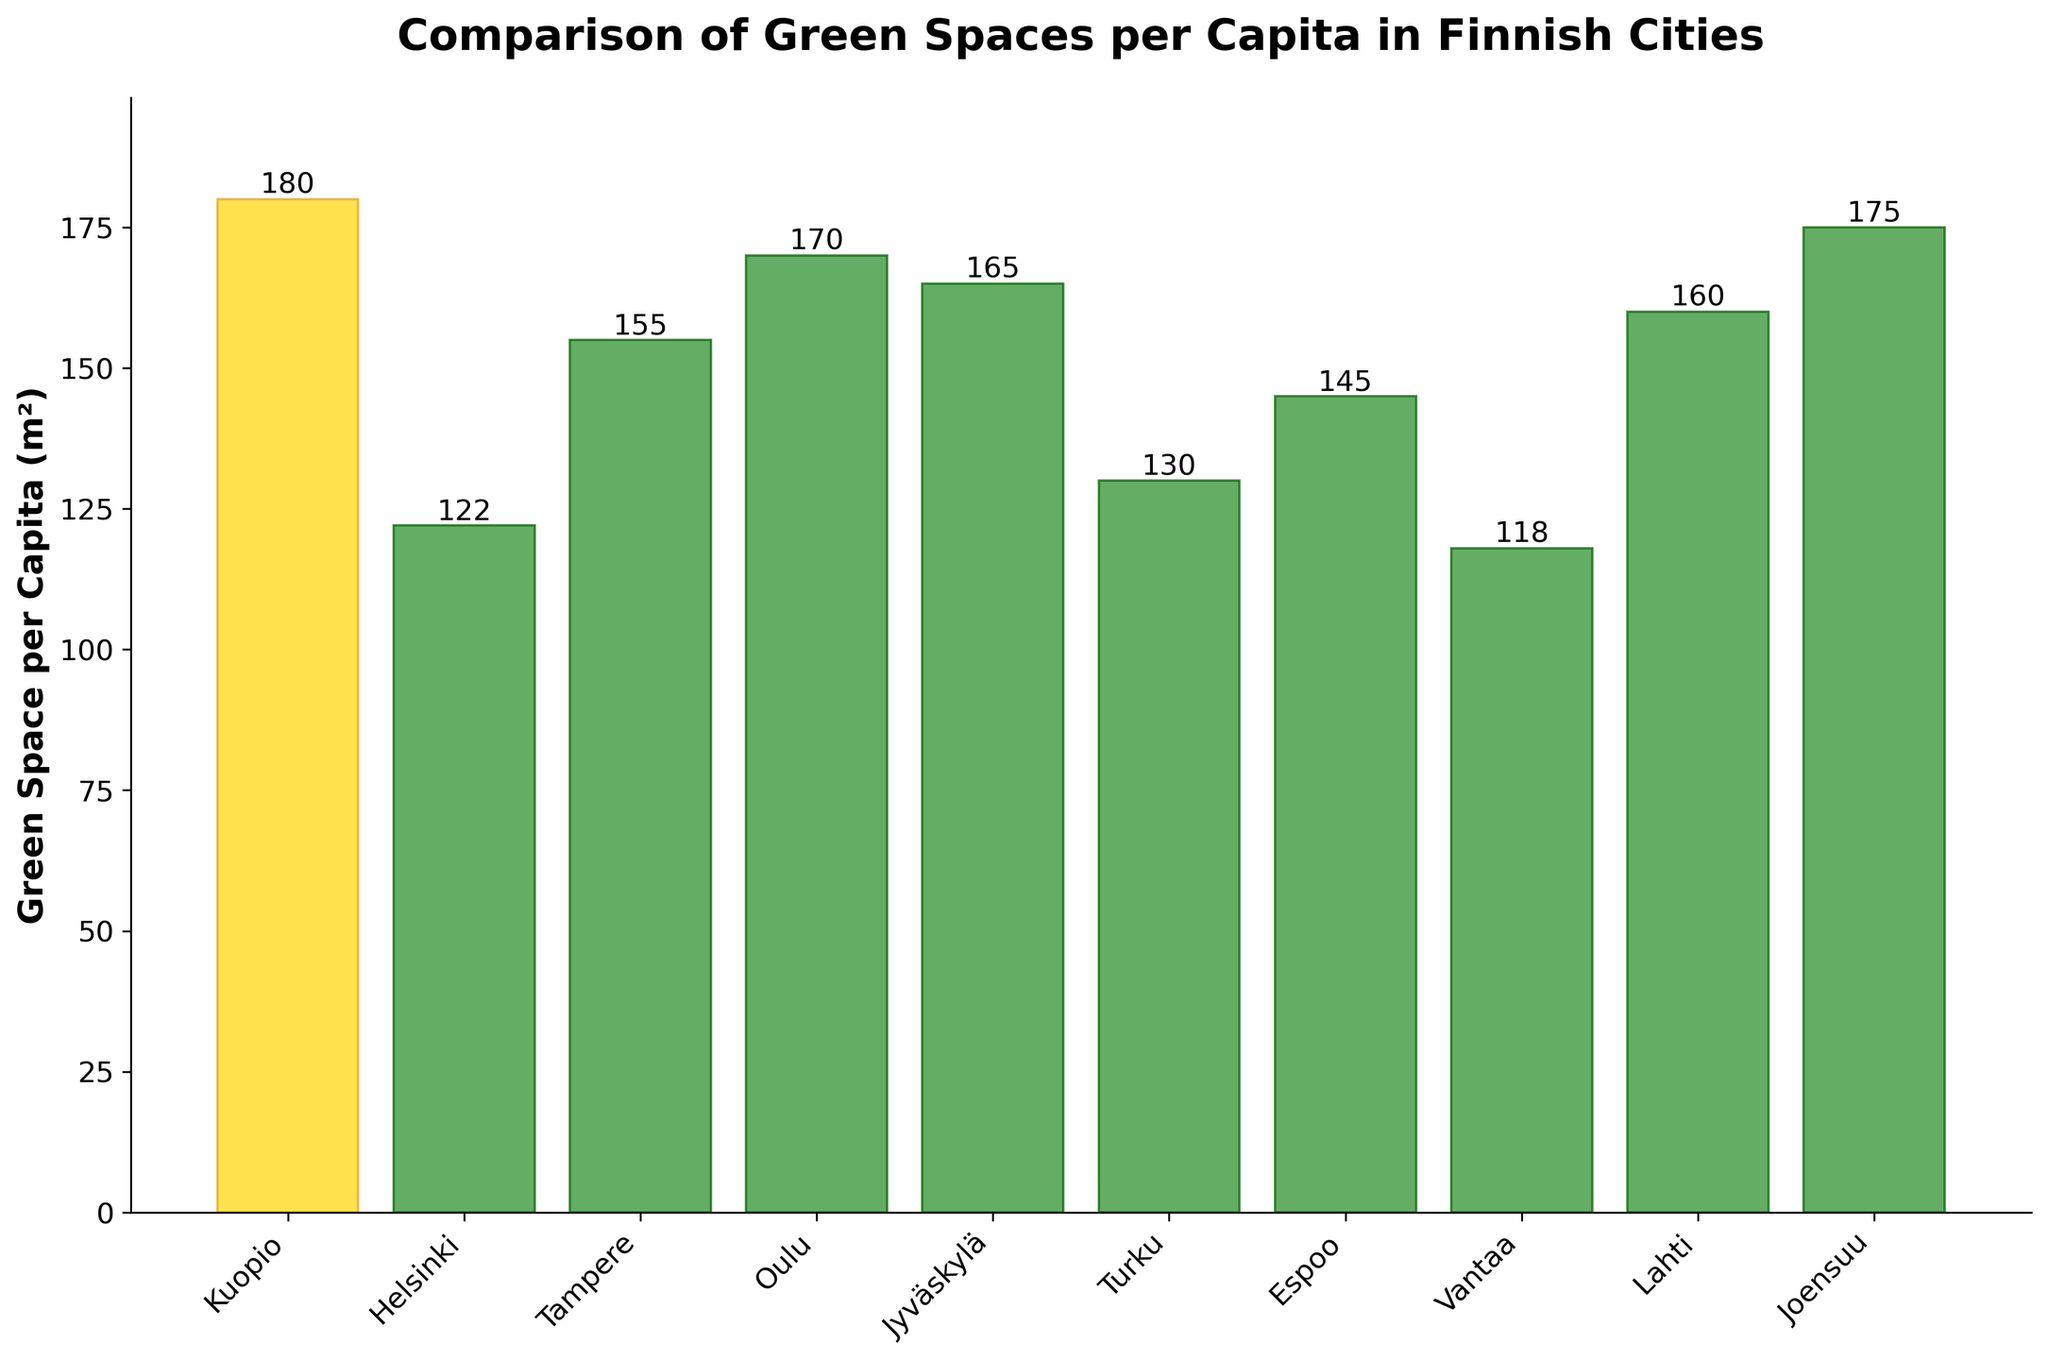What's the city with the highest green space per capita? The tallest bar indicates the highest value, which is Kuopio with 180 m².
Answer: Kuopio Which city has the smallest green space per capita? The shortest bar indicates the smallest value, which is Vantaa with 118 m².
Answer: Vantaa How much more green space per capita does Kuopio have compared to Helsinki? Kuopio has 180 m² and Helsinki has 122 m². The difference is 180 - 122 = 58 m².
Answer: 58 m² Which cities have more green space per capita than Tampere? Compare the values of cities to Tampere's 155 m². Kuopio (180 m²), Oulu (170 m²), Jyväskylä (165 m²), Joensuu (175 m²) all have more green space.
Answer: Kuopio, Oulu, Jyväskylä, Joensuu What is the median green space per capita? To find the median, list all values in ascending order: 118, 122, 130, 145, 155, 160, 165, 170, 175, 180. The median is the average of the 5th and 6th values: (155 + 160) / 2 = 157.5 m².
Answer: 157.5 m² How does the green space per capita in Kuopio compare to the average across all cities? Compute the mean: (180 + 122 + 155 + 170 + 165 + 130 + 145 + 118 + 160 + 175) / 10 = 1520 / 10 = 152 m². Kuopio's 180 m² is greater than this average.
Answer: 180 m² is greater Which city has the single longest green space per capita bar with a unique color? The unique color (gold) indicates Kuopio.
Answer: Kuopio 